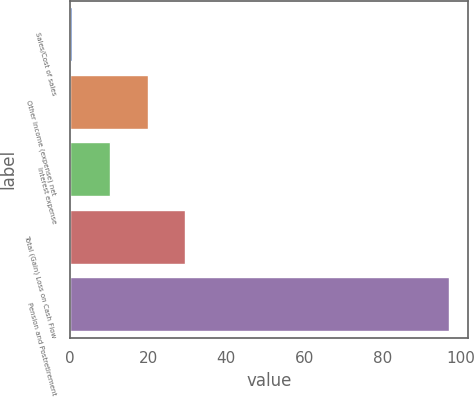Convert chart to OTSL. <chart><loc_0><loc_0><loc_500><loc_500><bar_chart><fcel>Sales/Cost of sales<fcel>Other income (expense) net<fcel>Interest expense<fcel>Total (Gain) Loss on Cash Flow<fcel>Pension and Postretirement<nl><fcel>0.6<fcel>19.88<fcel>10.24<fcel>29.52<fcel>97<nl></chart> 